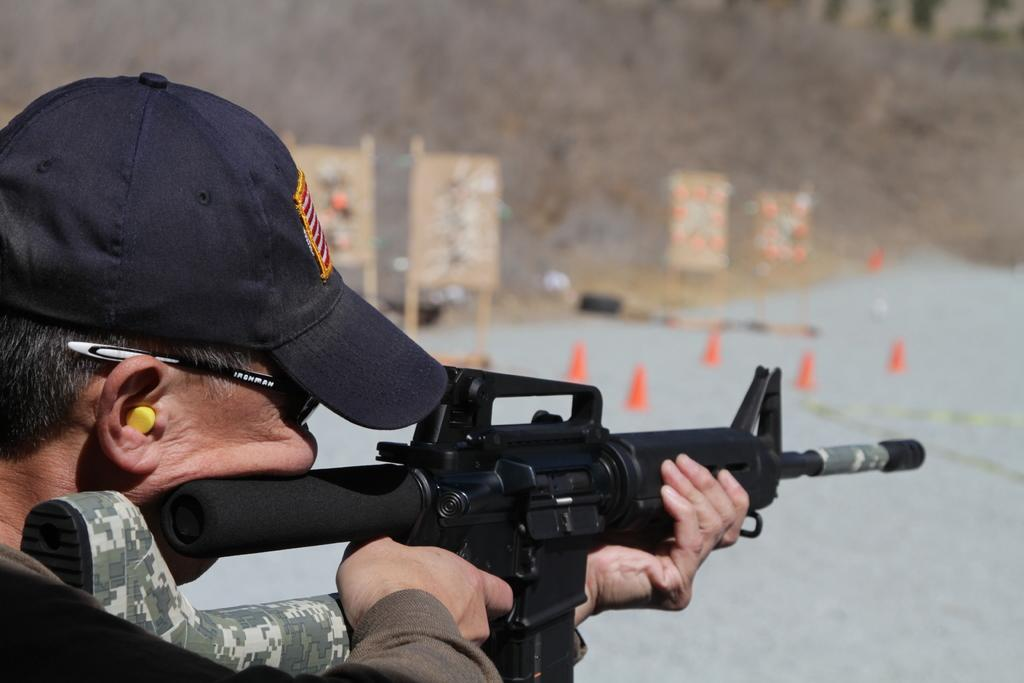What is located on the left side of the image? There is a man on the left side of the image. What is the man wearing on his head? The man is wearing a cap. What is the man wearing on his face? The man is wearing spectacles. What is the man holding in his hand? The man is holding a gun. What objects can be seen in the image that are used to direct traffic? There are traffic cones in the image. What type of vegetation is present in the image? There is dry grass in the image. How would you describe the background of the image? The background of the image is blurred. Can you see the man's toes in the image? There is no indication of the man's toes in the image, as he is wearing shoes and the focus is on his upper body. 